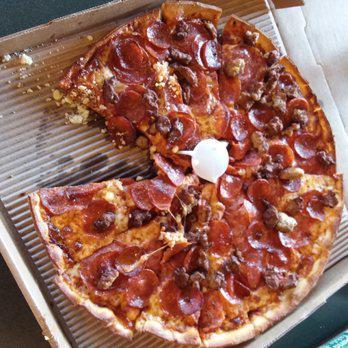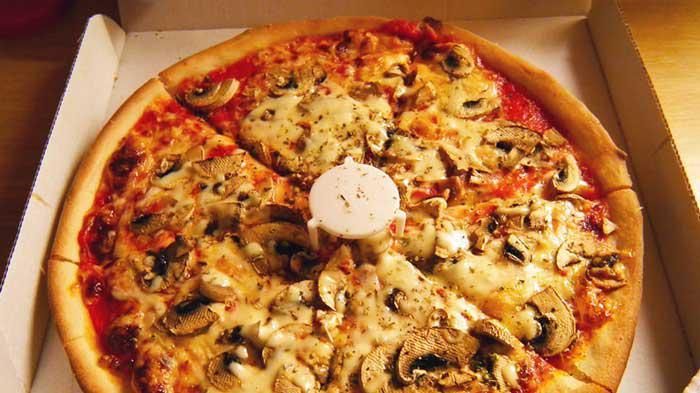The first image is the image on the left, the second image is the image on the right. Assess this claim about the two images: "There's a whole head of garlic and at least one tomato next to the pizza in one of the pictures.". Correct or not? Answer yes or no. No. The first image is the image on the left, the second image is the image on the right. Evaluate the accuracy of this statement regarding the images: "There is a pizza with exactly one missing slice.". Is it true? Answer yes or no. Yes. 